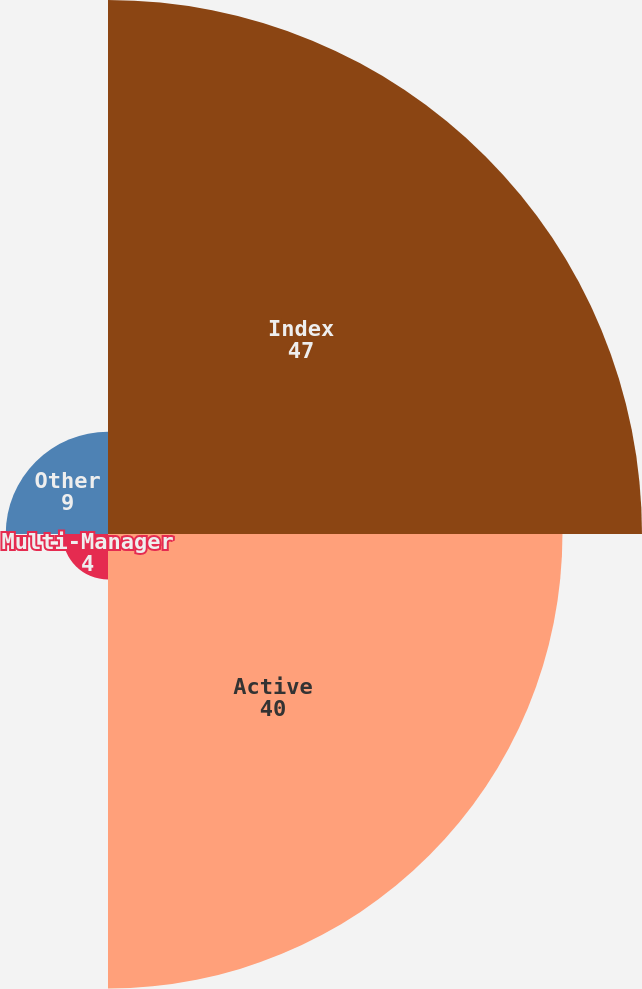Convert chart. <chart><loc_0><loc_0><loc_500><loc_500><pie_chart><fcel>Index<fcel>Active<fcel>Multi-Manager<fcel>Other<nl><fcel>47.0%<fcel>40.0%<fcel>4.0%<fcel>9.0%<nl></chart> 